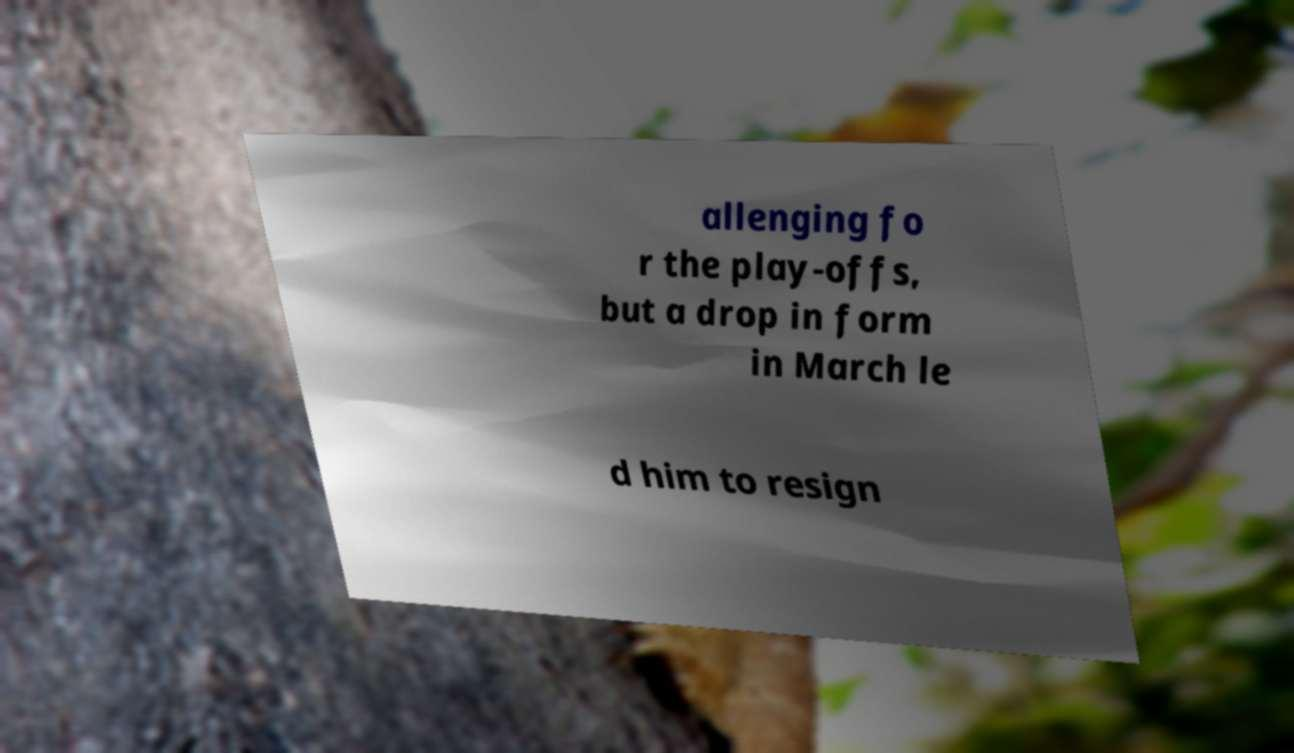There's text embedded in this image that I need extracted. Can you transcribe it verbatim? allenging fo r the play-offs, but a drop in form in March le d him to resign 